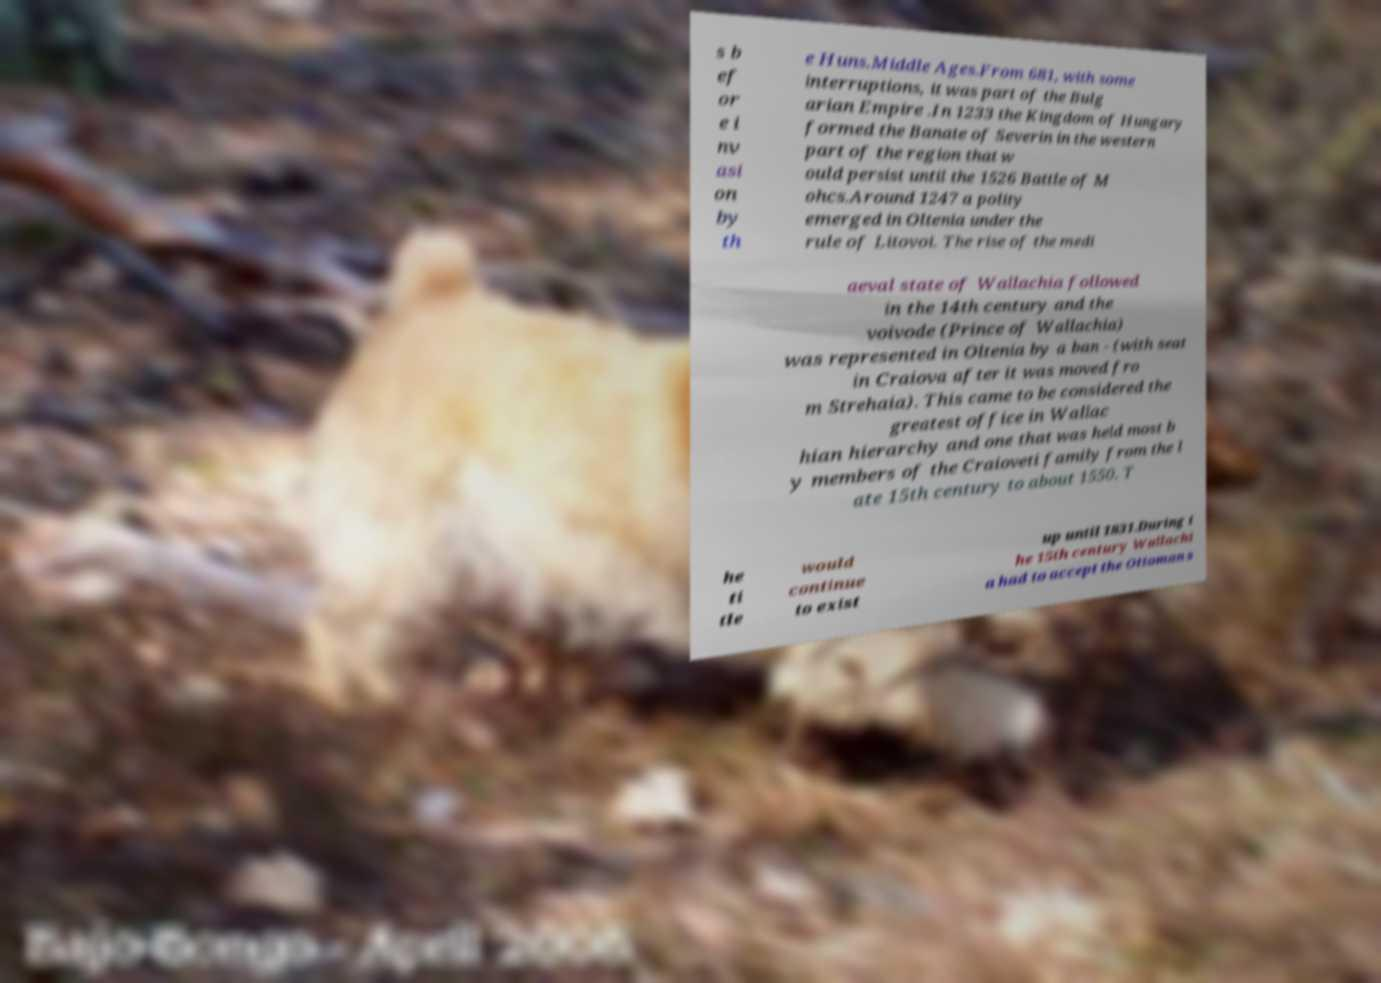I need the written content from this picture converted into text. Can you do that? s b ef or e i nv asi on by th e Huns.Middle Ages.From 681, with some interruptions, it was part of the Bulg arian Empire .In 1233 the Kingdom of Hungary formed the Banate of Severin in the western part of the region that w ould persist until the 1526 Battle of M ohcs.Around 1247 a polity emerged in Oltenia under the rule of Litovoi. The rise of the medi aeval state of Wallachia followed in the 14th century and the voivode (Prince of Wallachia) was represented in Oltenia by a ban - (with seat in Craiova after it was moved fro m Strehaia). This came to be considered the greatest office in Wallac hian hierarchy and one that was held most b y members of the Craioveti family from the l ate 15th century to about 1550. T he ti tle would continue to exist up until 1831.During t he 15th century Wallachi a had to accept the Ottoman s 